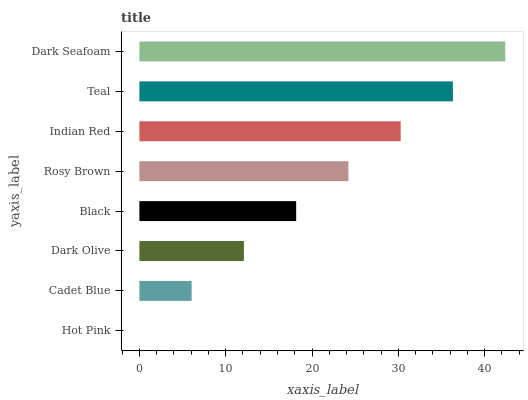Is Hot Pink the minimum?
Answer yes or no. Yes. Is Dark Seafoam the maximum?
Answer yes or no. Yes. Is Cadet Blue the minimum?
Answer yes or no. No. Is Cadet Blue the maximum?
Answer yes or no. No. Is Cadet Blue greater than Hot Pink?
Answer yes or no. Yes. Is Hot Pink less than Cadet Blue?
Answer yes or no. Yes. Is Hot Pink greater than Cadet Blue?
Answer yes or no. No. Is Cadet Blue less than Hot Pink?
Answer yes or no. No. Is Rosy Brown the high median?
Answer yes or no. Yes. Is Black the low median?
Answer yes or no. Yes. Is Dark Seafoam the high median?
Answer yes or no. No. Is Indian Red the low median?
Answer yes or no. No. 